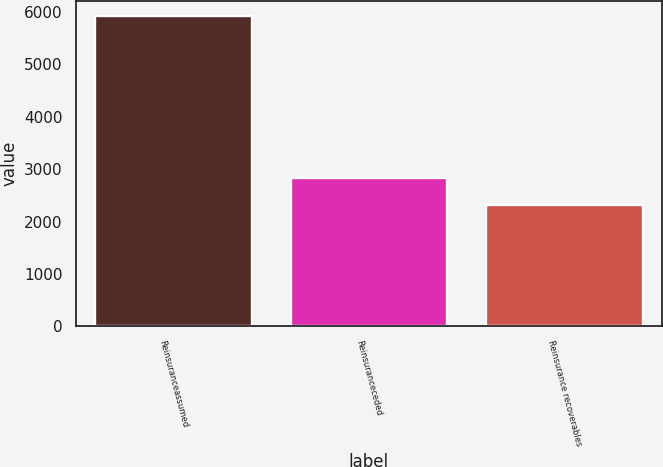Convert chart. <chart><loc_0><loc_0><loc_500><loc_500><bar_chart><fcel>Reinsuranceassumed<fcel>Reinsuranceceded<fcel>Reinsurance recoverables<nl><fcel>5918<fcel>2830<fcel>2313<nl></chart> 